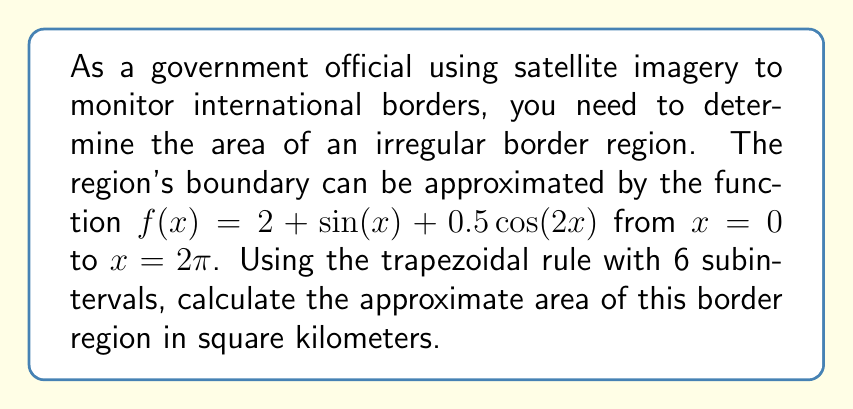Could you help me with this problem? To solve this problem, we'll use the trapezoidal rule for numerical integration. The steps are as follows:

1) The trapezoidal rule formula for n subintervals is:

   $$\int_{a}^{b} f(x) dx \approx \frac{b-a}{2n}[f(a) + 2f(x_1) + 2f(x_2) + ... + 2f(x_{n-1}) + f(b)]$$

2) Here, $a = 0$, $b = 2\pi$, and $n = 6$.

3) Calculate the width of each subinterval:
   $$\Delta x = \frac{b-a}{n} = \frac{2\pi - 0}{6} = \frac{\pi}{3}$$

4) Calculate the x-values for each point:
   $x_0 = 0$
   $x_1 = \frac{\pi}{3}$
   $x_2 = \frac{2\pi}{3}$
   $x_3 = \pi$
   $x_4 = \frac{4\pi}{3}$
   $x_5 = \frac{5\pi}{3}$
   $x_6 = 2\pi$

5) Calculate $f(x)$ for each of these x-values:
   $f(0) = 2 + \sin(0) + 0.5\cos(0) = 2.5$
   $f(\frac{\pi}{3}) = 2 + \sin(\frac{\pi}{3}) + 0.5\cos(\frac{2\pi}{3}) = 2.866$
   $f(\frac{2\pi}{3}) = 2 + \sin(\frac{2\pi}{3}) + 0.5\cos(\frac{4\pi}{3}) = 2.933$
   $f(\pi) = 2 + \sin(\pi) + 0.5\cos(2\pi) = 2.5$
   $f(\frac{4\pi}{3}) = 2 + \sin(\frac{4\pi}{3}) + 0.5\cos(\frac{8\pi}{3}) = 1.067$
   $f(\frac{5\pi}{3}) = 2 + \sin(\frac{5\pi}{3}) + 0.5\cos(\frac{10\pi}{3}) = 1.134$
   $f(2\pi) = 2 + \sin(2\pi) + 0.5\cos(4\pi) = 2.5$

6) Apply the trapezoidal rule:

   $$Area \approx \frac{\pi}{3} [2.5 + 2(2.866 + 2.933 + 2.5 + 1.067 + 1.134) + 2.5]$$
   $$= \frac{\pi}{3} [2.5 + 2(10.5) + 2.5]$$
   $$= \frac{\pi}{3} [23.5]$$
   $$= 24.609 \text{ km}^2$$

Therefore, the approximate area of the border region is 24.609 square kilometers.
Answer: 24.609 square kilometers 